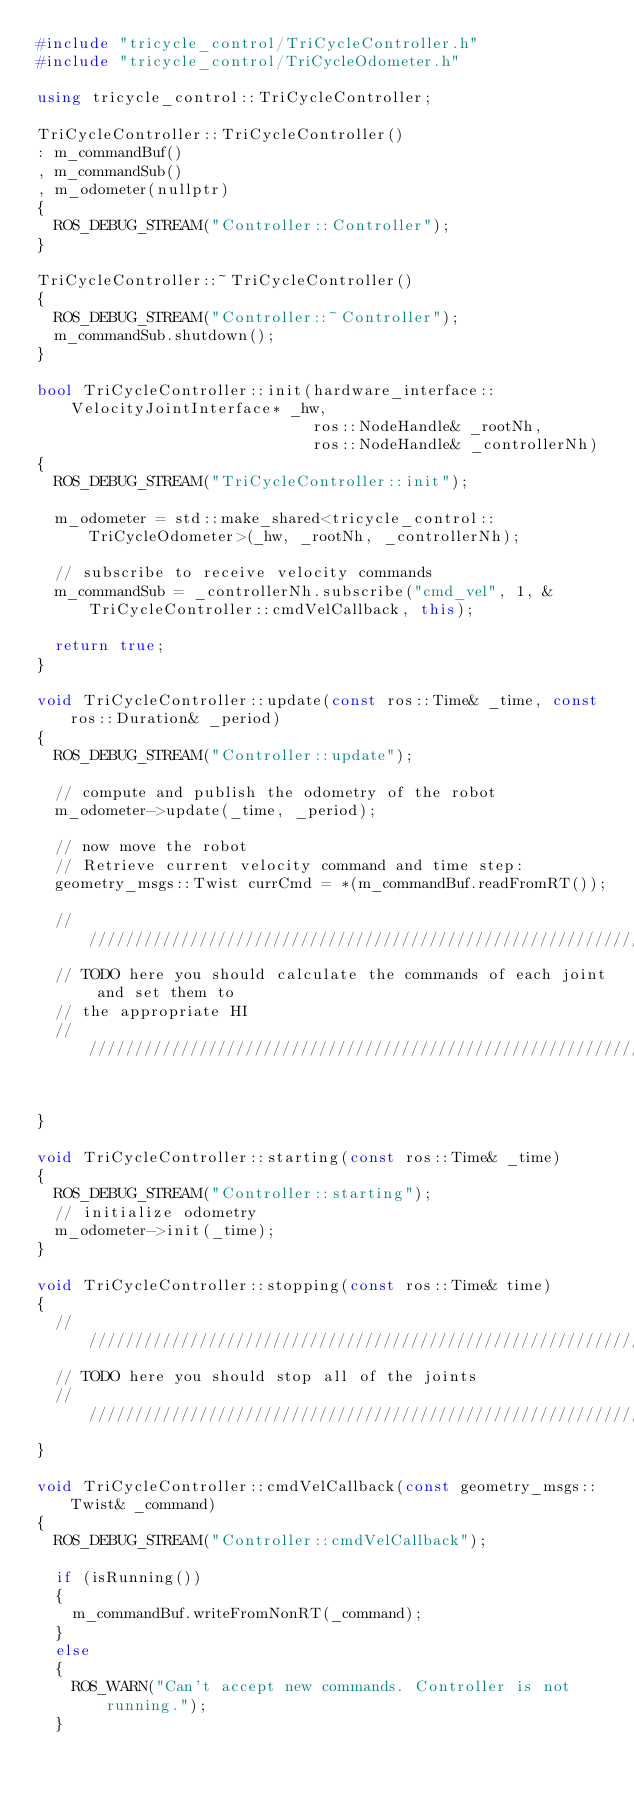Convert code to text. <code><loc_0><loc_0><loc_500><loc_500><_C++_>#include "tricycle_control/TriCycleController.h"
#include "tricycle_control/TriCycleOdometer.h"

using tricycle_control::TriCycleController;

TriCycleController::TriCycleController()
: m_commandBuf()
, m_commandSub()
, m_odometer(nullptr)
{
  ROS_DEBUG_STREAM("Controller::Controller");
}

TriCycleController::~TriCycleController()
{
  ROS_DEBUG_STREAM("Controller::~Controller");
  m_commandSub.shutdown();
}

bool TriCycleController::init(hardware_interface::VelocityJointInterface* _hw,
                              ros::NodeHandle& _rootNh,
                              ros::NodeHandle& _controllerNh)
{
  ROS_DEBUG_STREAM("TriCycleController::init");

  m_odometer = std::make_shared<tricycle_control::TriCycleOdometer>(_hw, _rootNh, _controllerNh);

  // subscribe to receive velocity commands
  m_commandSub = _controllerNh.subscribe("cmd_vel", 1, &TriCycleController::cmdVelCallback, this);

  return true;
}

void TriCycleController::update(const ros::Time& _time, const ros::Duration& _period)
{
  ROS_DEBUG_STREAM("Controller::update");

  // compute and publish the odometry of the robot
  m_odometer->update(_time, _period);

  // now move the robot
  // Retrieve current velocity command and time step:
  geometry_msgs::Twist currCmd = *(m_commandBuf.readFromRT());

  //////////////////////////////////////////////////////////////////////////////
  // TODO here you should calculate the commands of each joint and set them to
  // the appropriate HI
  //////////////////////////////////////////////////////////////////////////////


}

void TriCycleController::starting(const ros::Time& _time)
{
  ROS_DEBUG_STREAM("Controller::starting");
  // initialize odometry
  m_odometer->init(_time);
}

void TriCycleController::stopping(const ros::Time& time)
{
  //////////////////////////////////////////////////////////////////////////////
  // TODO here you should stop all of the joints
  //////////////////////////////////////////////////////////////////////////////
}

void TriCycleController::cmdVelCallback(const geometry_msgs::Twist& _command)
{
  ROS_DEBUG_STREAM("Controller::cmdVelCallback");

  if (isRunning())
  {
    m_commandBuf.writeFromNonRT(_command);
  }
  else
  {
    ROS_WARN("Can't accept new commands. Controller is not running.");
  }</code> 